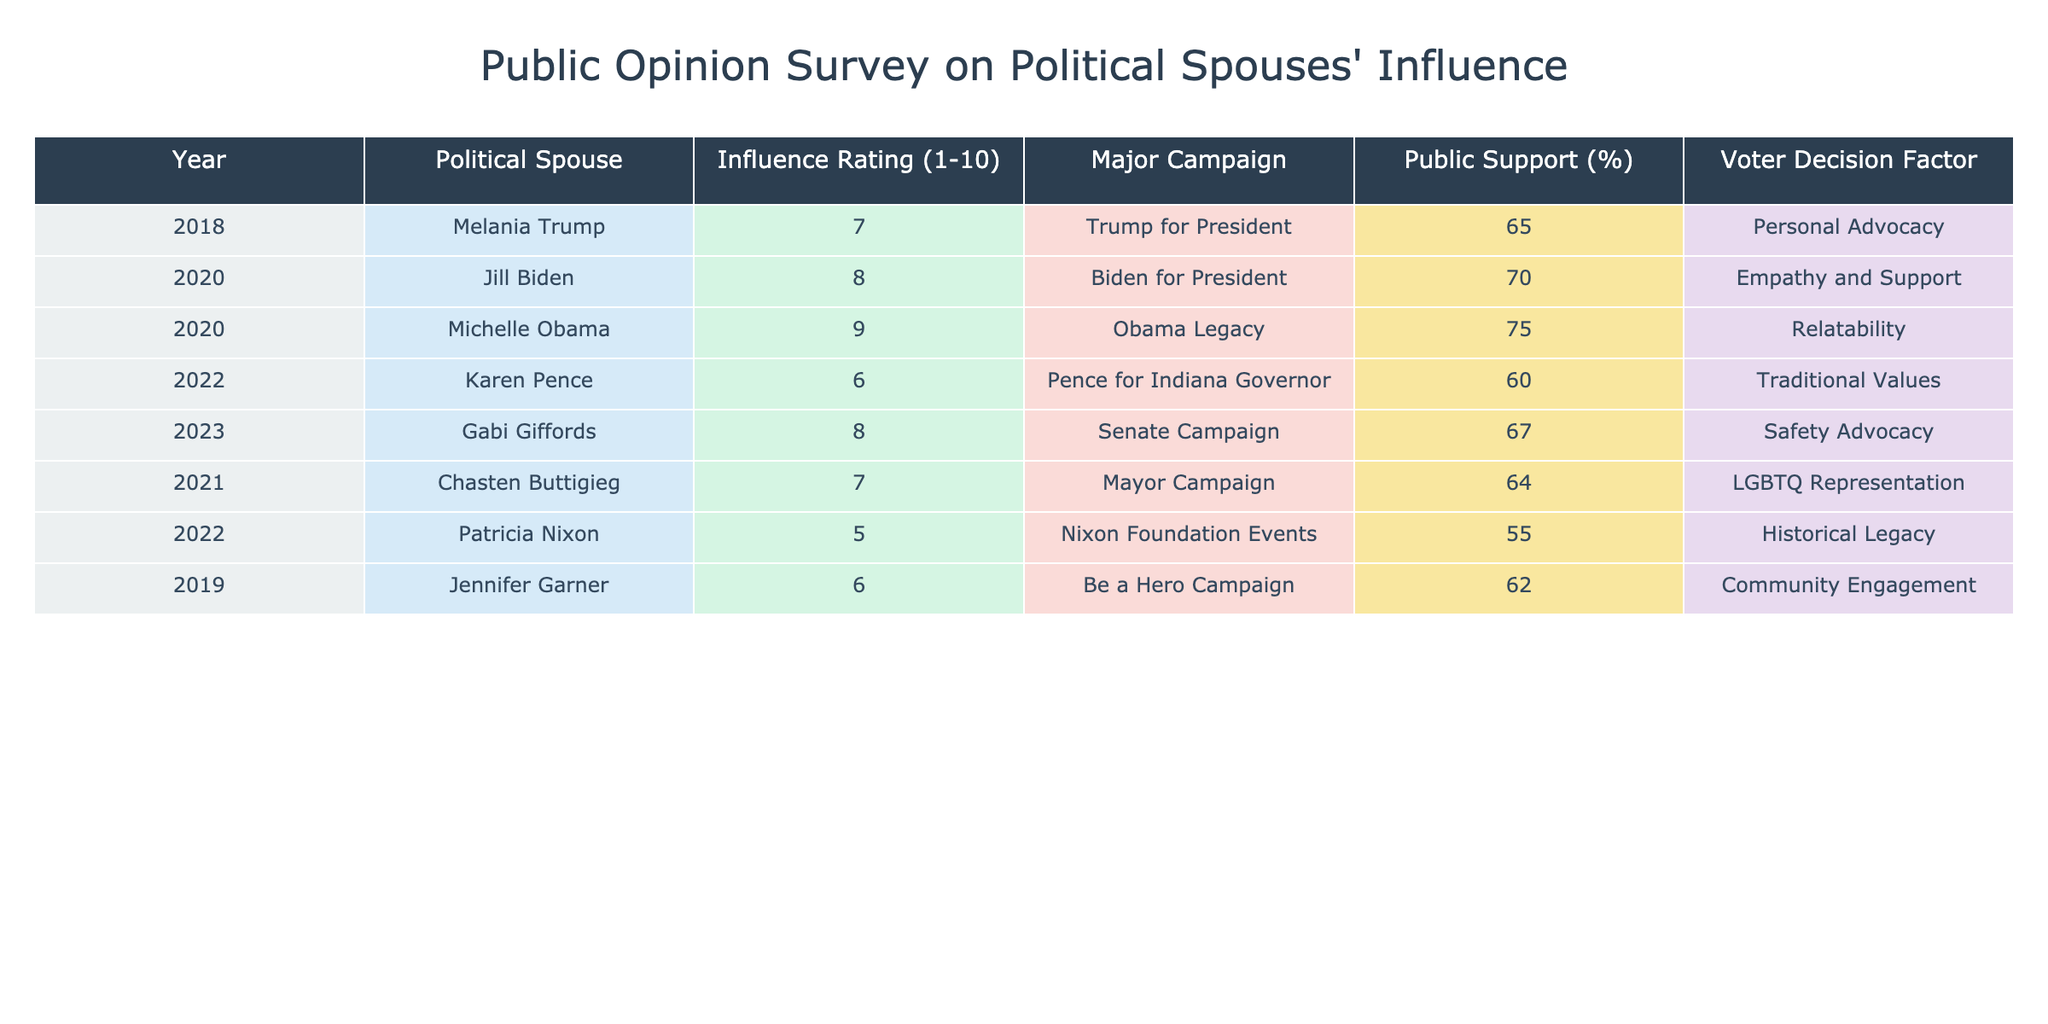What is the highest influence rating among the political spouses listed? The influence ratings are as follows: Melania Trump (7), Jill Biden (8), Michelle Obama (9), Karen Pence (6), Gabi Giffords (8), Chasten Buttigieg (7), Patricia Nixon (5), and Jennifer Garner (6). The highest rating is from Michelle Obama at 9.
Answer: 9 How many political spouses had an influence rating of 6 or lower? The spouses with ratings of 6 or lower are: Karen Pence (6), Patricia Nixon (5), and Jennifer Garner (6). That totals 3 spouses.
Answer: 3 What is the average public support percentage for all political spouses in the table? The public support percentages are: 65, 70, 75, 60, 67, 64, 55, and 62. Adding these gives 65 + 70 + 75 + 60 + 67 + 64 + 55 + 62 =  549, and since there are 8 data points, we divide by 8 to get 549/8 = 68.625. The rounded average is approximately 69%.
Answer: 69% Did any political spouse have an influence rating of 5 or less? Looking through the influence ratings, the only spouse at 5 or lower is Patricia Nixon, who has a rating of 5. Therefore, the answer is yes.
Answer: Yes Which political spouse had the highest public support and what was that percentage? The public support percentages listed are: 65%, 70%, 75%, 60%, 67%, 64%, 55%, and 62%. The highest value is 75%, attributed to Michelle Obama.
Answer: 75% (Michelle Obama) What is the difference in influence rating between Michelle Obama and Patricia Nixon? Michelle Obama has an influence rating of 9, while Patricia Nixon has a rating of 5. The difference is calculated as 9 - 5 = 4.
Answer: 4 How many spouses had their influence ratings greater than 7? The spouses with ratings greater than 7 are Jill Biden (8), Michelle Obama (9), and Gabi Giffords (8). This results in a total of 3 spouses.
Answer: 3 Which factor for voter decision did Gabi Giffords represent? The data shows that Gabi Giffords was linked to "Safety Advocacy" as her voter decision factor.
Answer: Safety Advocacy 